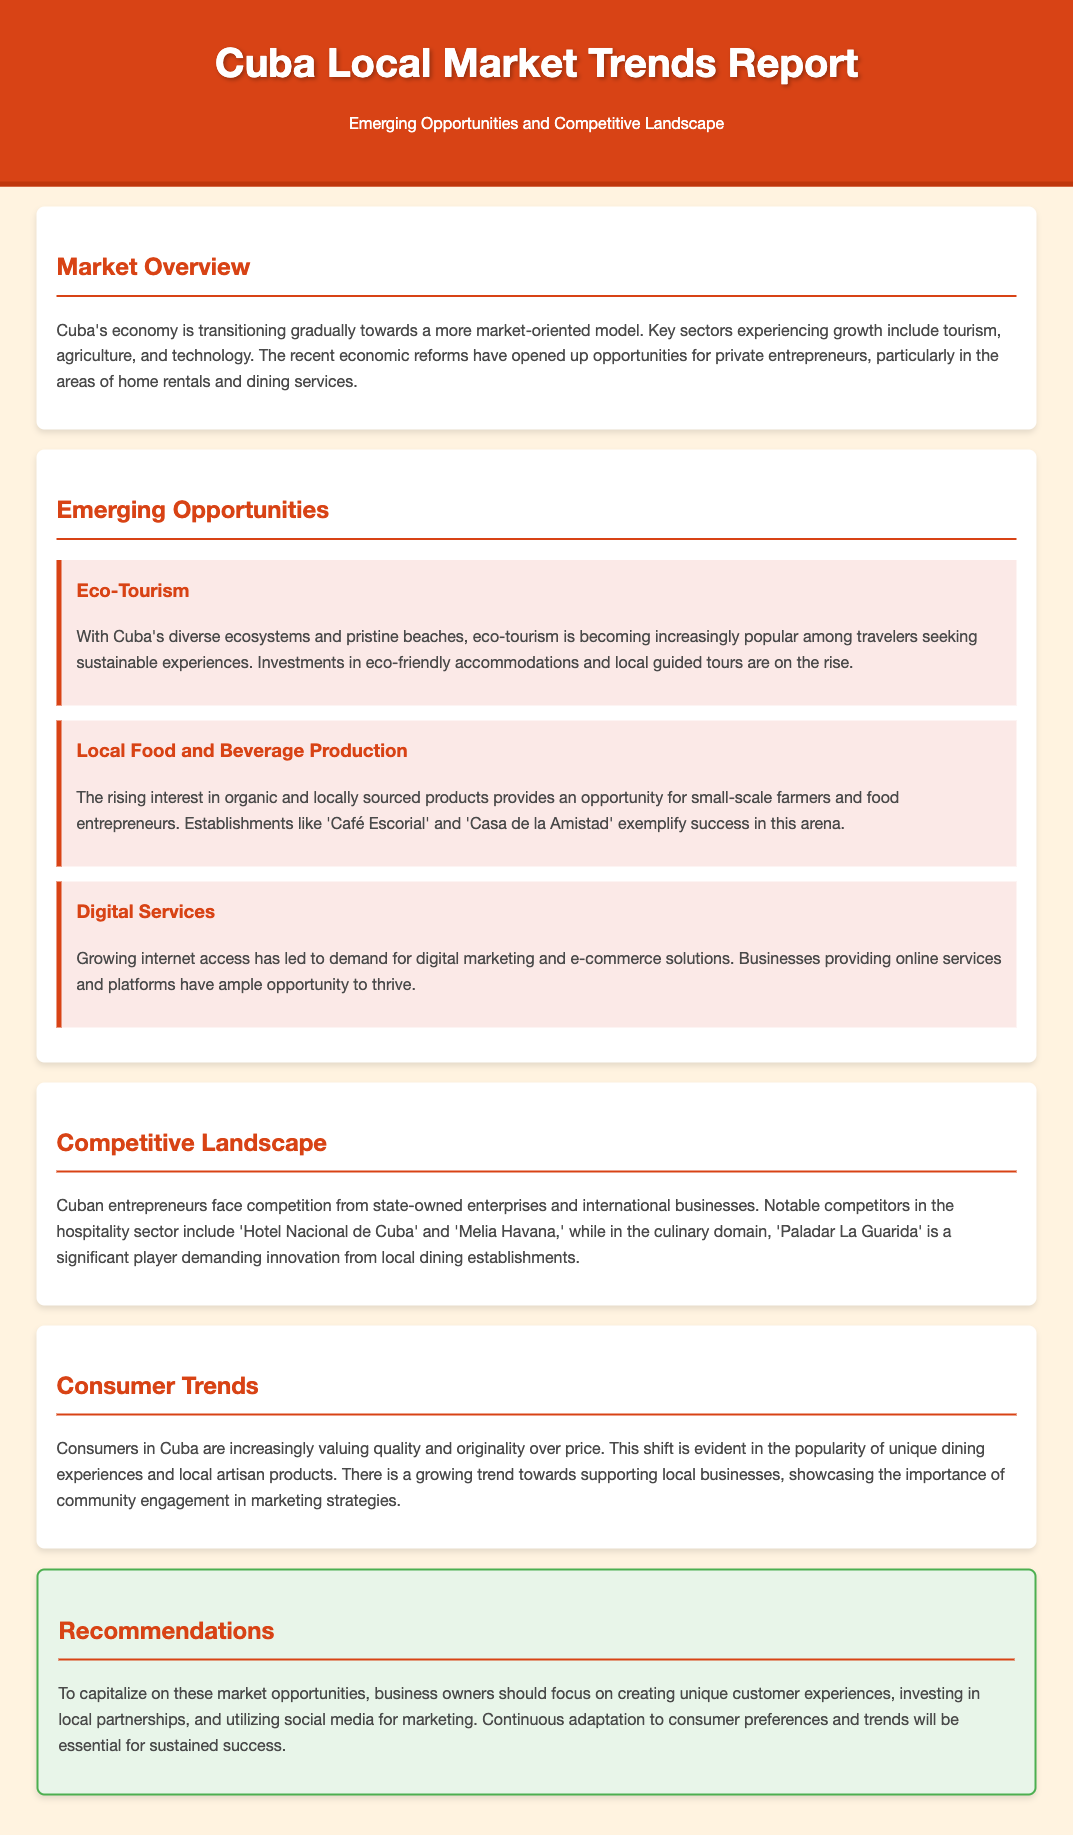what are the key sectors experiencing growth in Cuba? The document mentions that the key sectors experiencing growth in Cuba include tourism, agriculture, and technology.
Answer: tourism, agriculture, and technology what is an emerging opportunity in eco-tourism? The document states that investments in eco-friendly accommodations and local guided tours are on the rise due to the popularity of eco-tourism.
Answer: eco-friendly accommodations and local guided tours who are significant competitors in the hospitality sector? According to the document, notable competitors in the hospitality sector include Hotel Nacional de Cuba and Melia Havana.
Answer: Hotel Nacional de Cuba and Melia Havana what consumer trend is increasing in Cuba? The document notes that consumers are increasingly valuing quality and originality over price.
Answer: quality and originality what is the recommendation for business owners to capitalize on market opportunities? The document recommends that business owners focus on creating unique customer experiences to capitalize on market opportunities.
Answer: creating unique customer experiences what is a noted establishment in local food and beverage production? The document provides 'Café Escorial' and 'Casa de la Amistad' as examples of success in local food and beverage production.
Answer: Café Escorial and Casa de la Amistad what is the impact of growing internet access on businesses? The document explains that growing internet access has led to demand for digital marketing and e-commerce solutions.
Answer: demand for digital marketing and e-commerce solutions which trend shows the importance of community engagement? The document indicates that there is a growing trend toward supporting local businesses, showcasing the importance of community engagement in marketing strategies.
Answer: supporting local businesses 